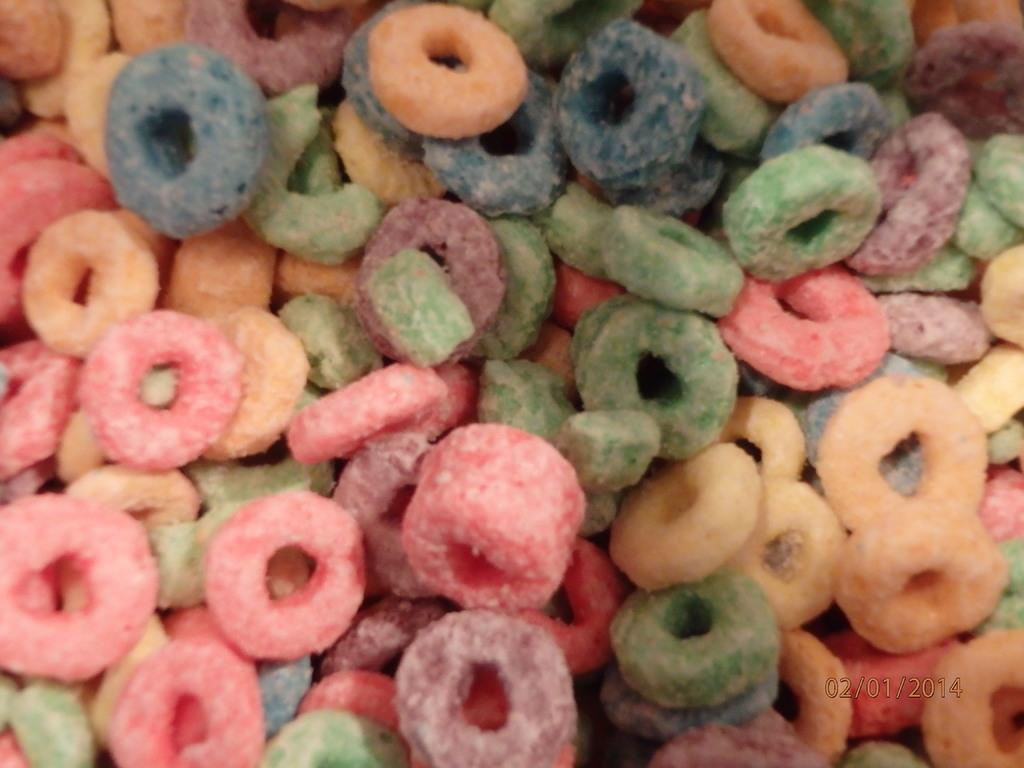Can you describe this image briefly? In this image we can see the colored food items. In the bottom right corner we can see the date. 